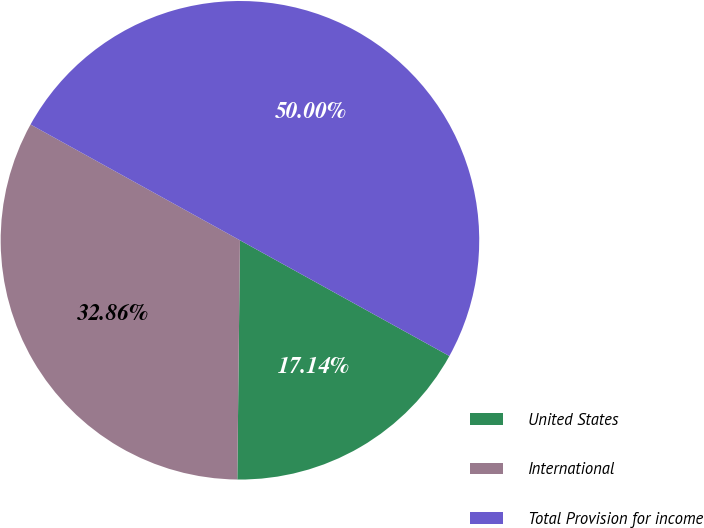<chart> <loc_0><loc_0><loc_500><loc_500><pie_chart><fcel>United States<fcel>International<fcel>Total Provision for income<nl><fcel>17.14%<fcel>32.86%<fcel>50.0%<nl></chart> 